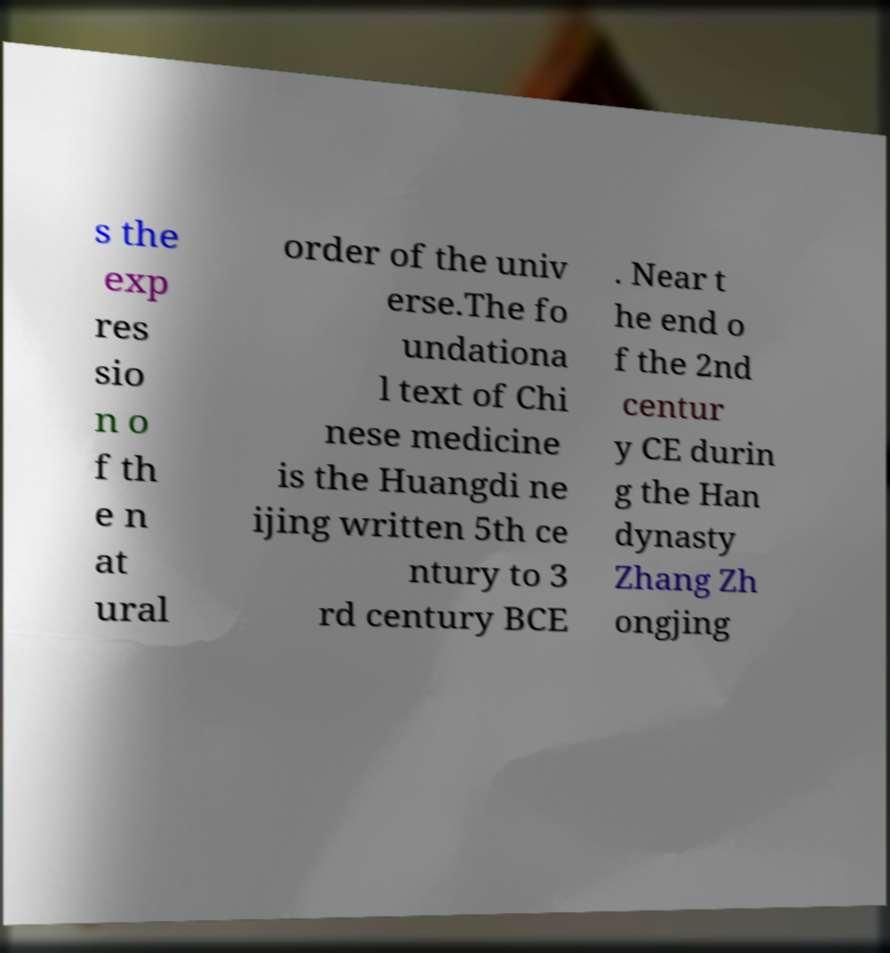For documentation purposes, I need the text within this image transcribed. Could you provide that? s the exp res sio n o f th e n at ural order of the univ erse.The fo undationa l text of Chi nese medicine is the Huangdi ne ijing written 5th ce ntury to 3 rd century BCE . Near t he end o f the 2nd centur y CE durin g the Han dynasty Zhang Zh ongjing 